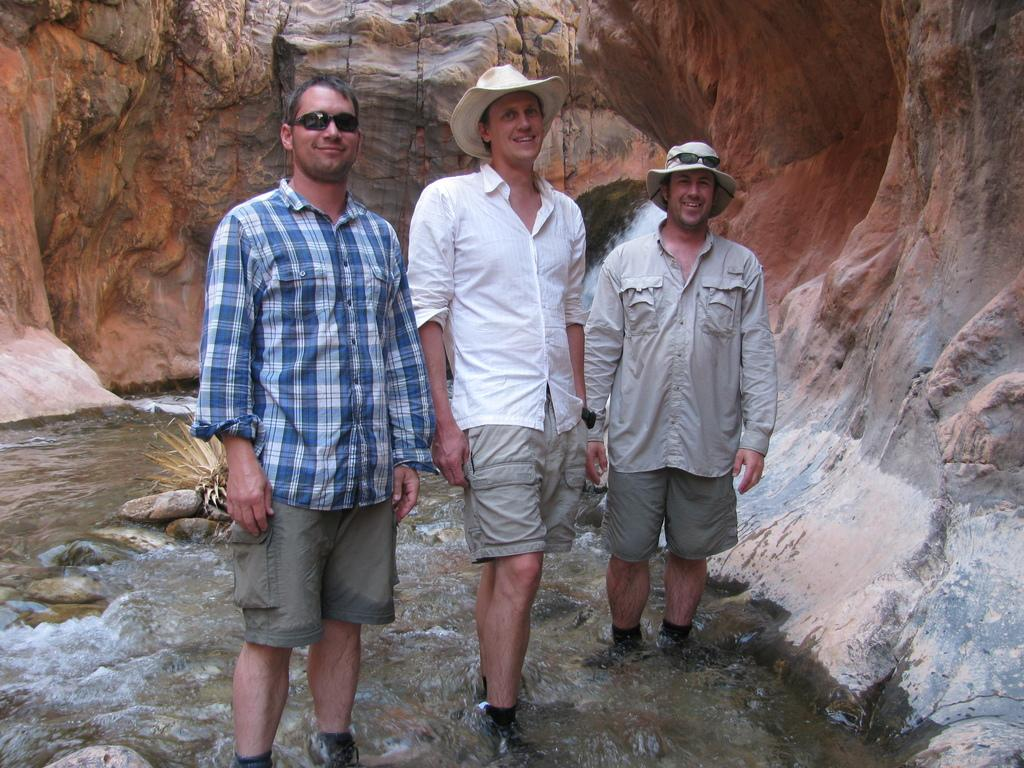How many people are in the image? There are three men in the image. What are the men doing in the image? The men are smiling in the image. Where are the men located in the image? The men are standing in water in the image. What else can be seen in the water besides the men? There is a plant and rocks in the water. What can be seen in the background of the image? There are rocks visible in the background of the image. What type of authority figure can be seen in the image? There is no authority figure present in the image; it features three men standing in water. How many fowl are visible in the image? There are no fowl present in the image; it features three men standing in water with a plant and rocks. 